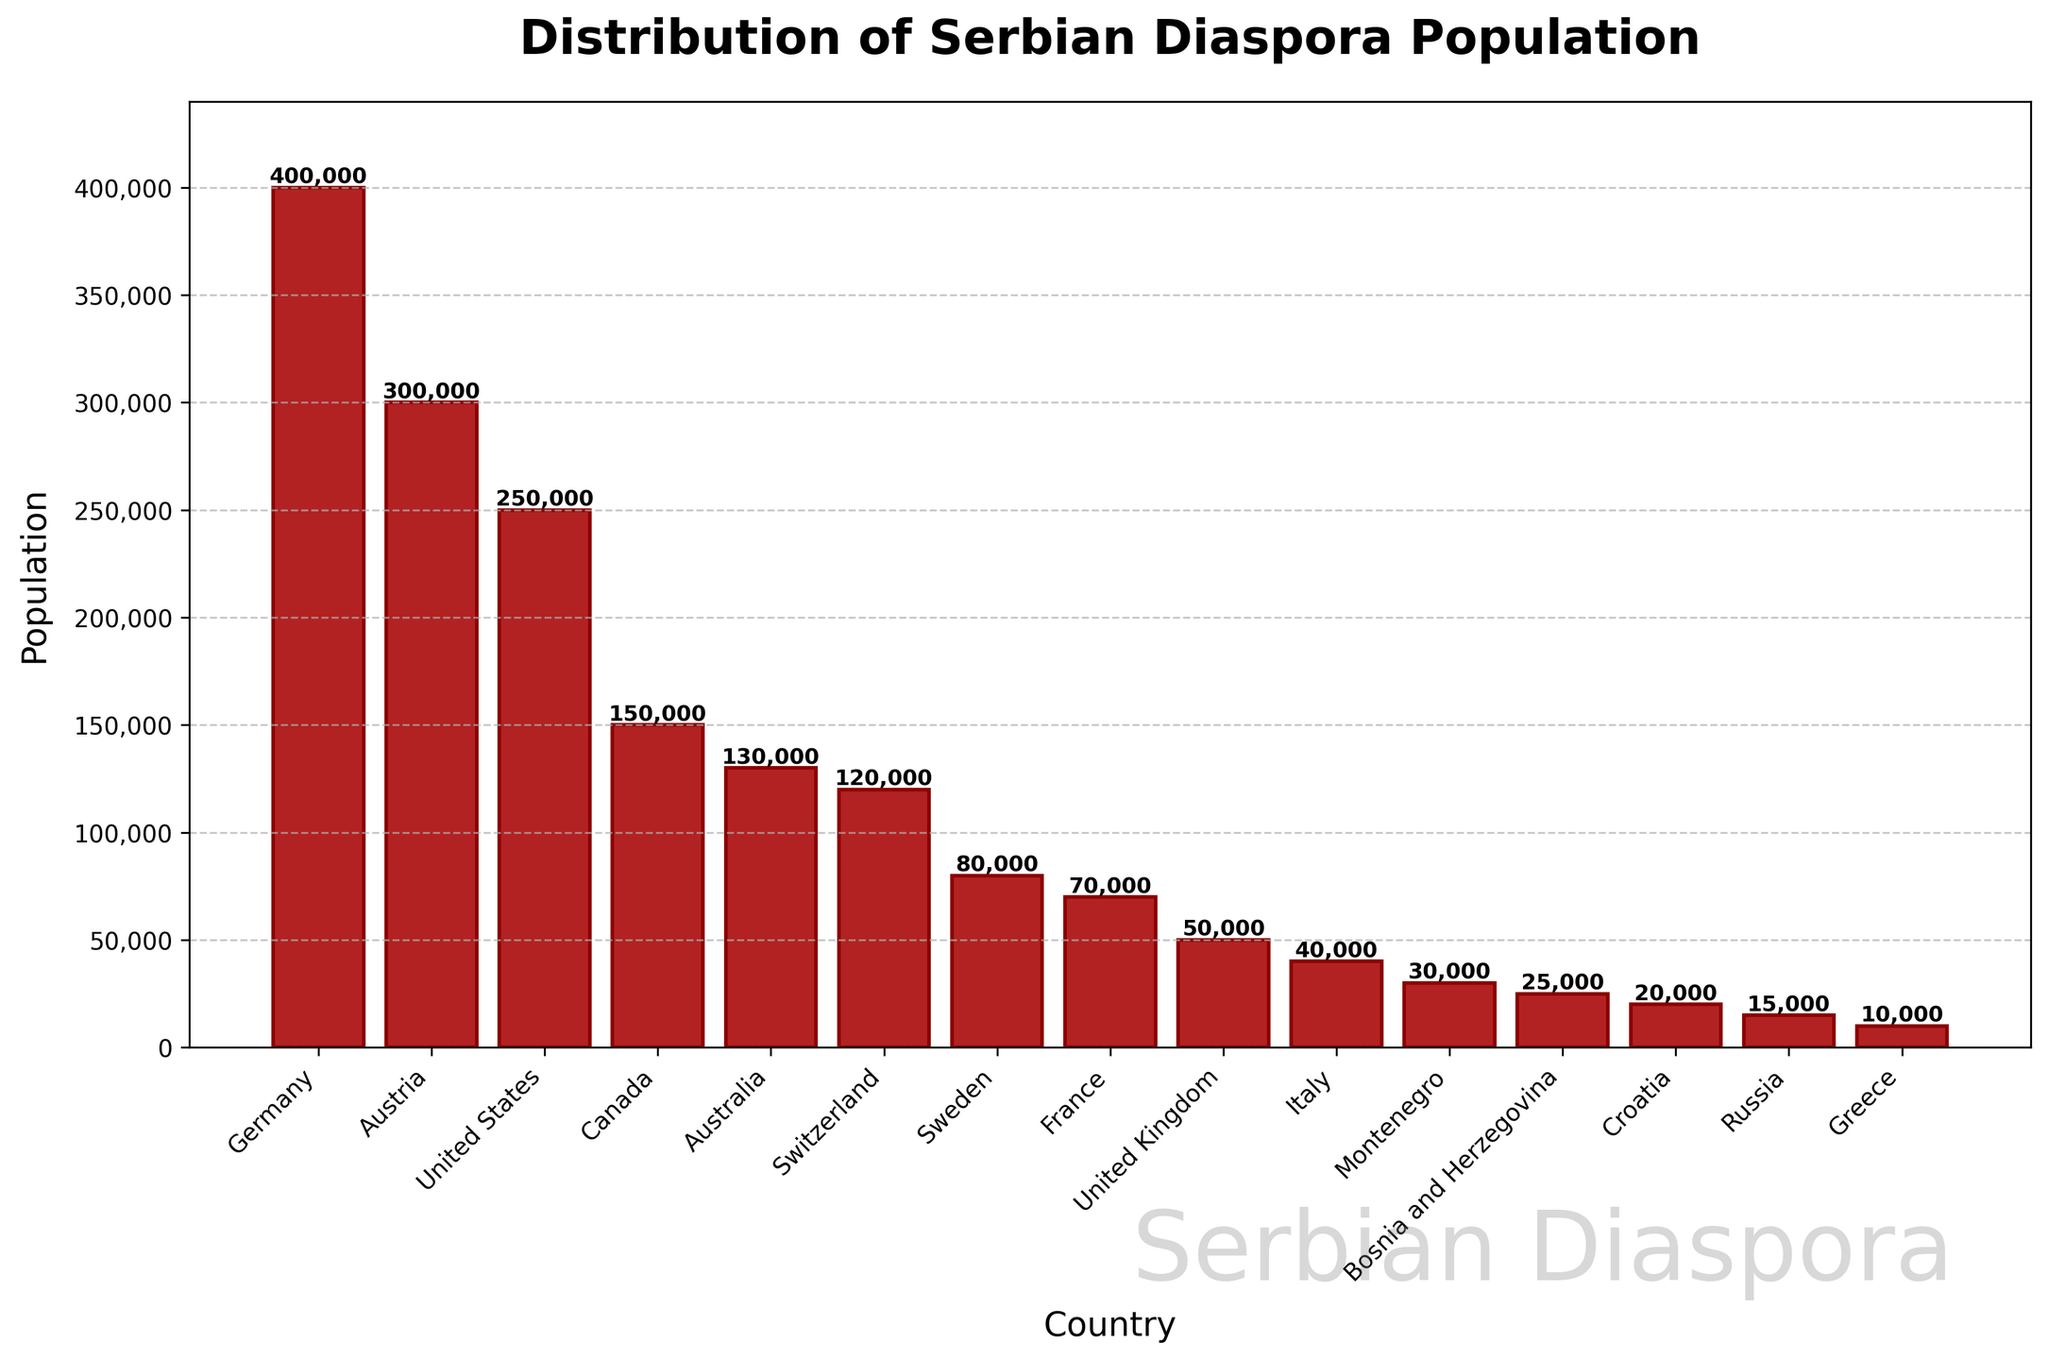Which country has the highest population of Serbian diaspora? The highest bar represents the country with the largest Serbian diaspora population. Germany has the highest bar with 400,000 people.
Answer: Germany How does the Serbian diaspora population in Russia compare to Greece? Look at the heights of the bars for Russia and Greece. The bar for Russia is slightly higher than the bar for Greece with populations of 15,000 and 10,000 respectively.
Answer: Russia > Greece What is the combined population of Serbian diaspora in Canada and Australia? Locate the bars for Canada and Australia and add their populations: 150,000 (Canada) + 130,000 (Australia) = 280,000.
Answer: 280,000 Which country has a larger Serbian diaspora population, France or Switzerland? By visually comparing the heights of the bars for France and Switzerland, it is clear that Switzerland has a higher bar representing a larger population of 120,000 compared to France's 70,000.
Answer: Switzerland What's the total Serbian diaspora population in Austria, United States, and United Kingdom combined? Add the populations of Austria (300,000), United States (250,000), and United Kingdom (50,000): 300,000 + 250,000 + 50,000 = 600,000.
Answer: 600,000 How does the Serbian diaspora in Italy compare to that in Sweden? The heights of the bars for Italy and Sweden show that Sweden has a significantly higher population (80,000) compared to Italy (40,000).
Answer: Sweden > Italy What is the difference in Serbian diaspora population between Germany and Canada? Subtract Canada's population (150,000) from Germany's population (400,000): 400,000 - 150,000 = 250,000.
Answer: 250,000 Is the Serbian diaspora population in France equal to or greater than in Montenegro? By comparing the heights of the bars, it is evident that France (70,000) has a larger Serbian diaspora population than Montenegro (30,000).
Answer: France > Montenegro 